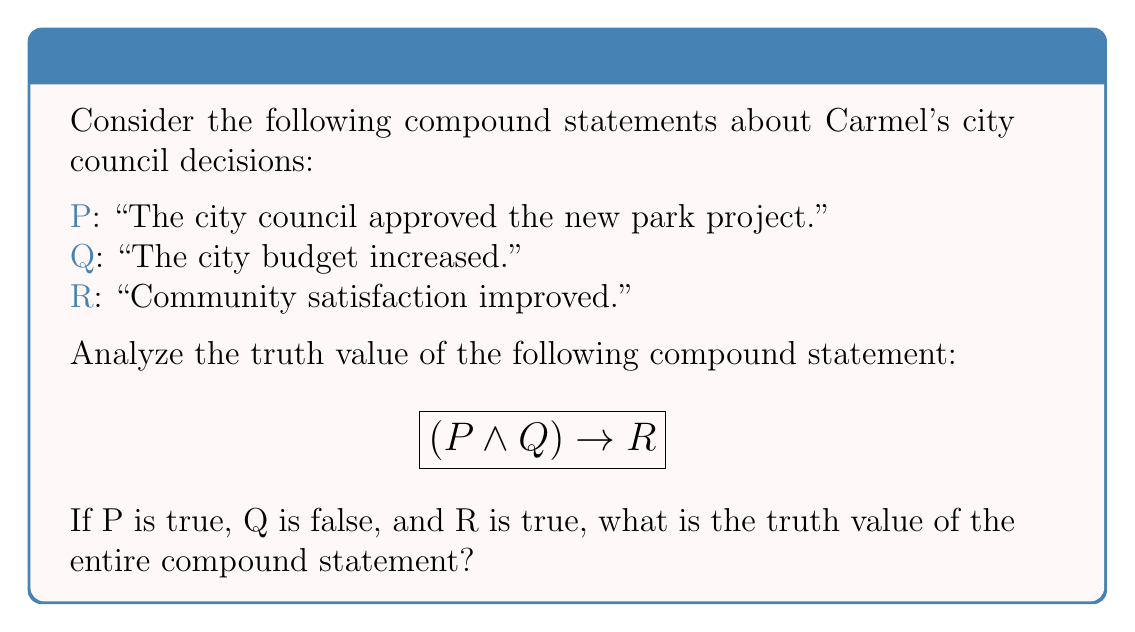Provide a solution to this math problem. Let's approach this step-by-step:

1) First, recall the truth table for the logical AND operation ($\land$):
   
   $$
   \begin{array}{c|c|c}
   P & Q & P \land Q \\
   \hline
   T & T & T \\
   T & F & F \\
   F & T & F \\
   F & F & F
   \end{array}
   $$

2) We're given that P is true and Q is false. So, $P \land Q$ is false.

3) Now, let's recall the truth table for the implication ($\rightarrow$):

   $$
   \begin{array}{c|c|c}
   P & Q & P \rightarrow Q \\
   \hline
   T & T & T \\
   T & F & F \\
   F & T & T \\
   F & F & T
   \end{array}
   $$

4) In our compound statement $(P \land Q) \rightarrow R$, we've determined that $(P \land Q)$ is false, and we're given that R is true.

5) Looking at the implication truth table, when the antecedent (left side) is false and the consequent (right side) is true, the implication is true.

Therefore, the entire compound statement $(P \land Q) \rightarrow R$ is true.
Answer: True 